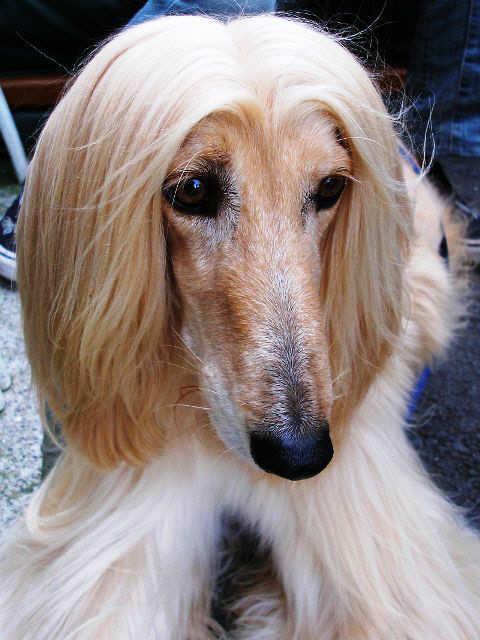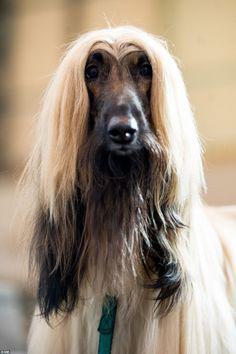The first image is the image on the left, the second image is the image on the right. For the images displayed, is the sentence "The dog on the left has its muzzle pointing slightly rightward, and the dog on the right has a darker muzzle that the rest of its fur or the dog on the left." factually correct? Answer yes or no. Yes. 